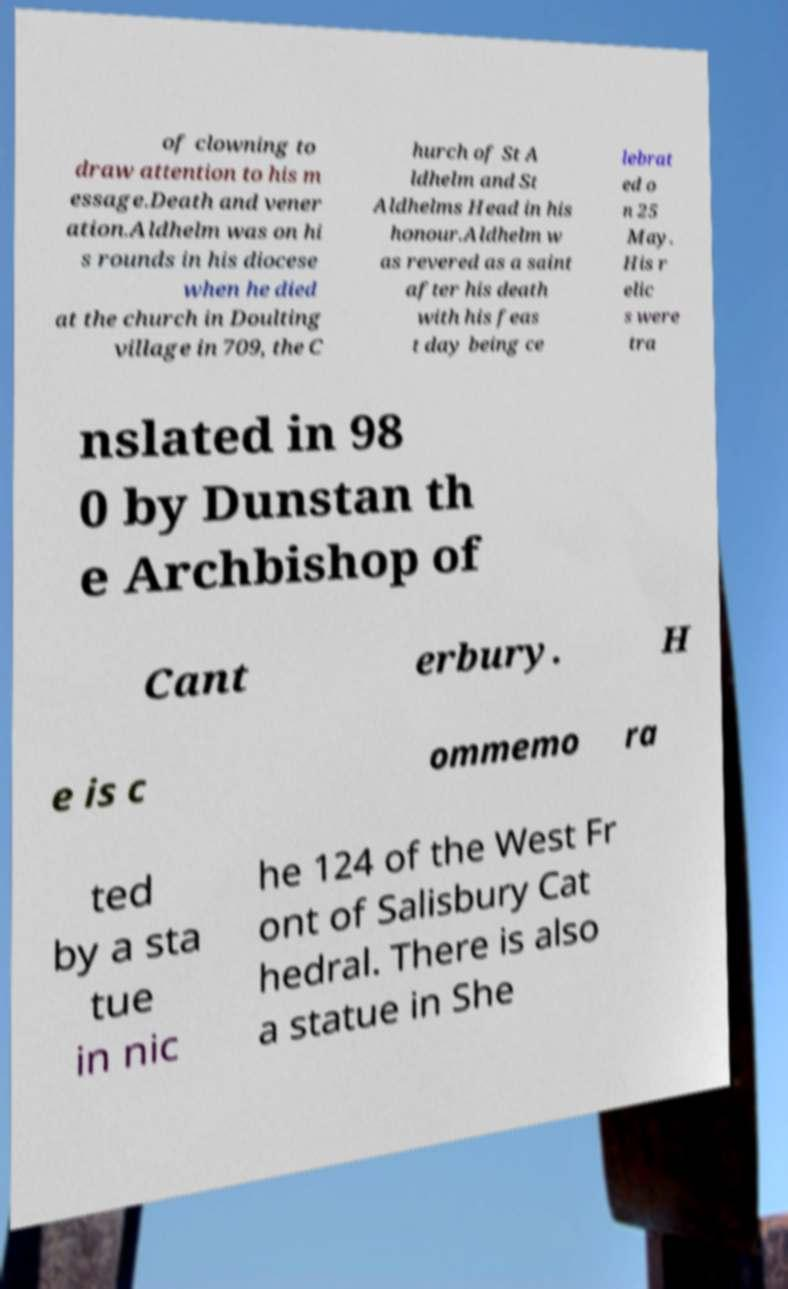Can you read and provide the text displayed in the image?This photo seems to have some interesting text. Can you extract and type it out for me? of clowning to draw attention to his m essage.Death and vener ation.Aldhelm was on hi s rounds in his diocese when he died at the church in Doulting village in 709, the C hurch of St A ldhelm and St Aldhelms Head in his honour.Aldhelm w as revered as a saint after his death with his feas t day being ce lebrat ed o n 25 May. His r elic s were tra nslated in 98 0 by Dunstan th e Archbishop of Cant erbury. H e is c ommemo ra ted by a sta tue in nic he 124 of the West Fr ont of Salisbury Cat hedral. There is also a statue in She 